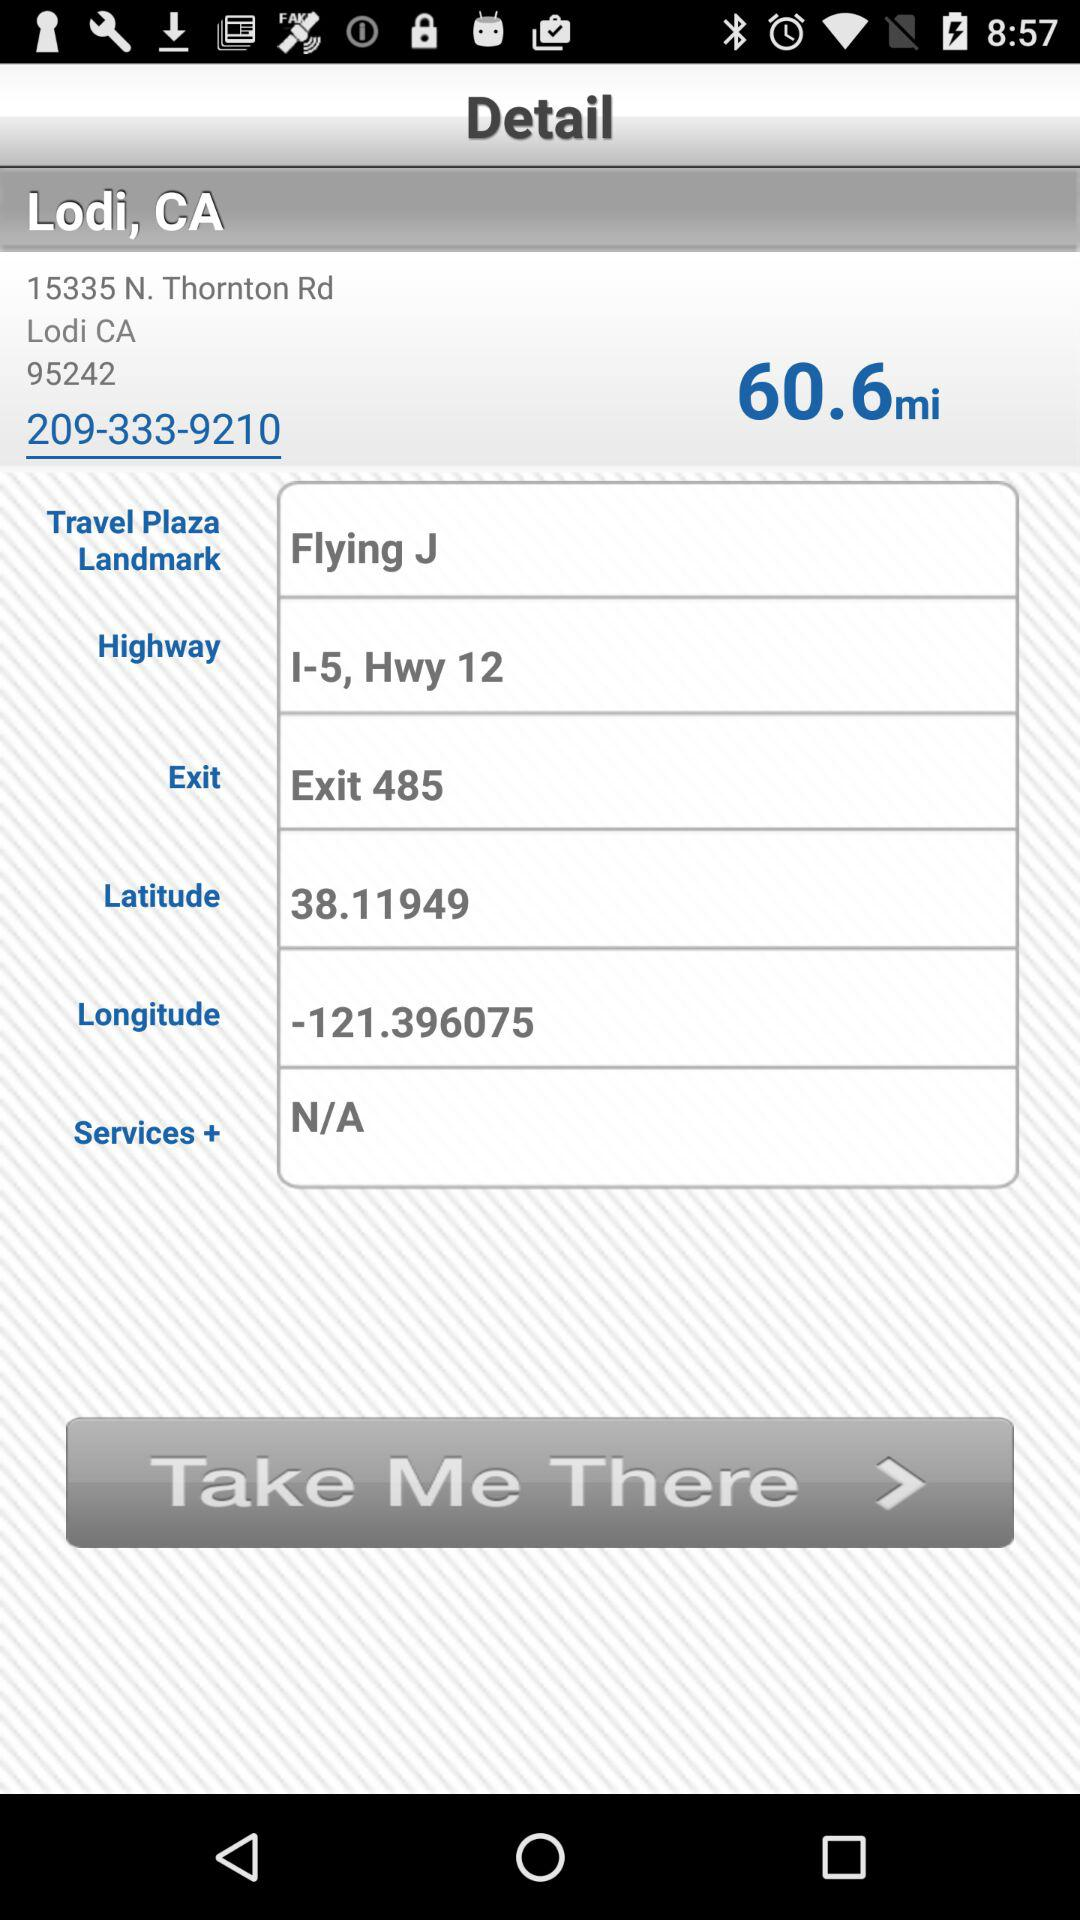What is the exit point? The exit point is 485. 